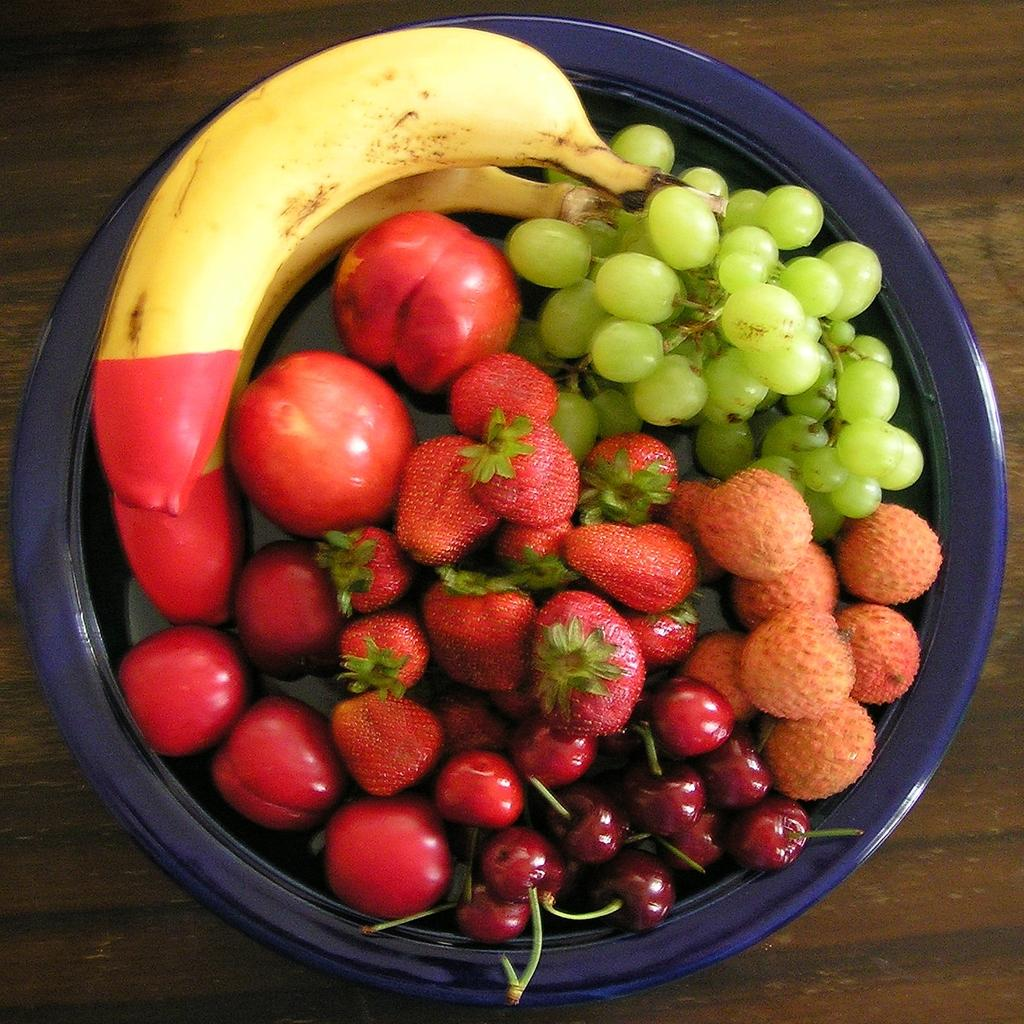What type of table is in the image? There is a wooden table in the image. What is on the table? There is a bowl of fruits on the table. What specific fruits can be seen in the bowl? Bananas, grapes, strawberries, and cherries are present in the bowl. Are there any other fruits in the bowl besides the ones mentioned? Yes, there are other unspecified fruits present in the bowl. What type of test is being conducted on the fruits in the image? There is no test being conducted on the fruits in the image; the image simply shows a bowl of fruits on a wooden table. 